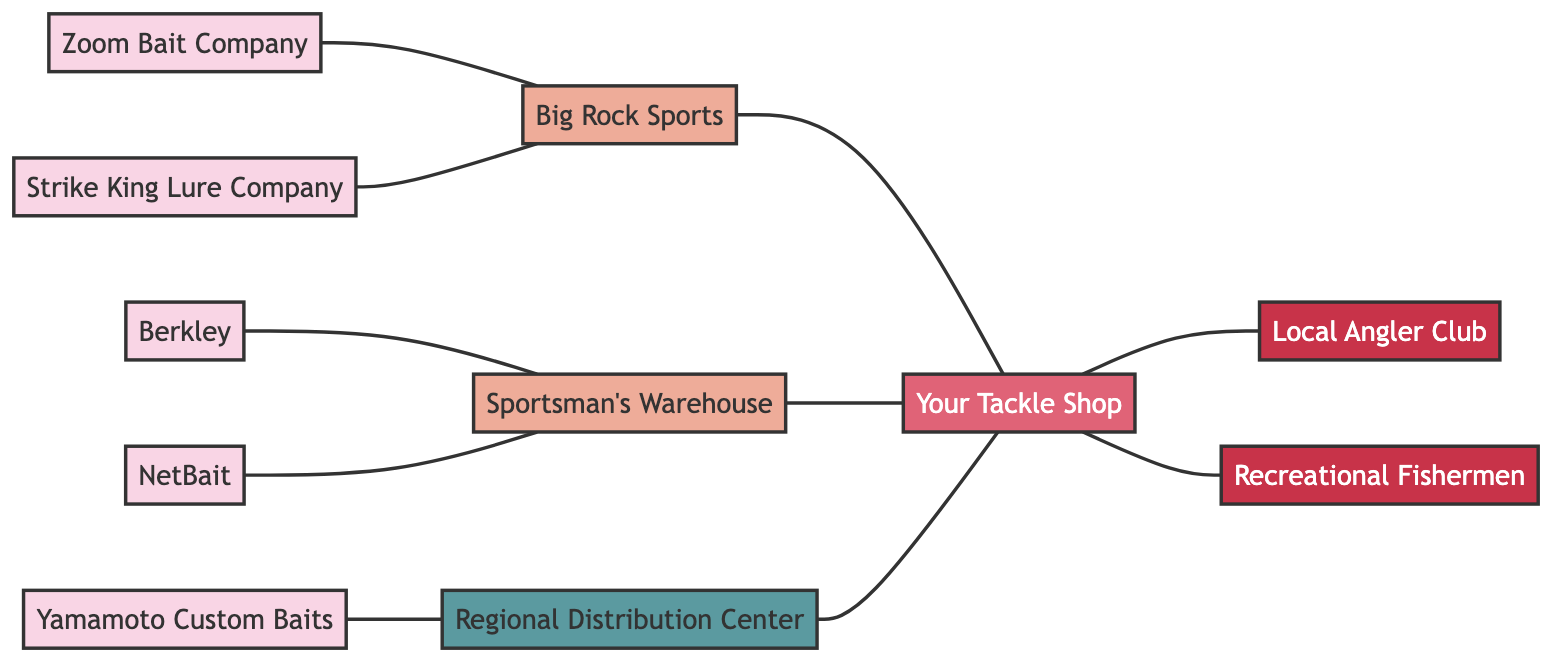How many suppliers are there in the network? To find the number of suppliers, we can count the nodes labeled as suppliers in the diagram. There are five suppliers: Zoom Bait Company, Strike King Lure Company, Berkley, Yamamoto Custom Baits, and NetBait.
Answer: 5 Which distributor connects to Zoom Bait Company? Looking at the edges connected to Zoom Bait Company, we see that the edge connects it to Big Rock Sports.
Answer: Big Rock Sports What is the main connection from the warehouse? The warehouse connects directly to Your Tackle Shop. This is the only edge from the warehouse to another node.
Answer: Your Tackle Shop Who are the customers of Your Tackle Shop? By examining the edges connected to Your Tackle Shop, we can see that it is linked to the Local Angler Club and Recreational Fishermen.
Answer: Local Angler Club, Recreational Fishermen What is the total number of edges in the diagram? To determine the number of edges, we count all the connections between nodes. There are ten edges in total connecting the suppliers, distributors, warehouse, tackle shop, and customers.
Answer: 10 Which supplier is connected to Sportsman's Warehouse? Checking the edges from Sportsman's Warehouse, we find it connects to Berkley and NetBait. This means both suppliers supply through this distributor.
Answer: Berkley, NetBait Which node has the most connections in this network? Analyzing the edges, Your Tackle Shop has three direct connections from Big Rock Sports, Sportsman's Warehouse, and the Regional Distribution Center, making it the node with the most connections.
Answer: Your Tackle Shop Which type of node is the Regional Distribution Center? The label for Regional Distribution Center shows it is categorized as a warehouse in the diagram.
Answer: Warehouse 